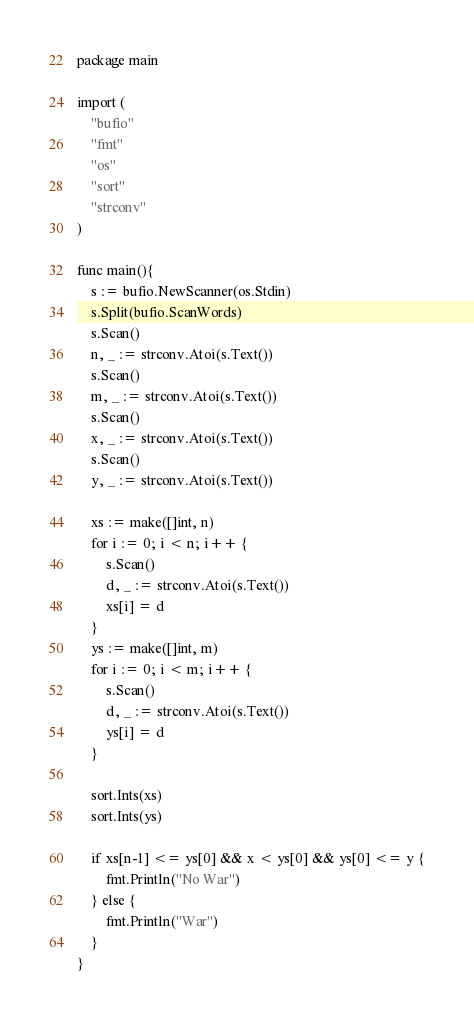Convert code to text. <code><loc_0><loc_0><loc_500><loc_500><_Go_>package main

import (
    "bufio"
    "fmt"
    "os"
    "sort"
    "strconv"
)    

func main(){
    s := bufio.NewScanner(os.Stdin)
    s.Split(bufio.ScanWords)
    s.Scan()
    n, _ := strconv.Atoi(s.Text())
    s.Scan()
    m, _ := strconv.Atoi(s.Text())
    s.Scan()
    x, _ := strconv.Atoi(s.Text())
    s.Scan()
    y, _ := strconv.Atoi(s.Text())
    
    xs := make([]int, n)
    for i := 0; i < n; i++ {
        s.Scan()
        d, _ := strconv.Atoi(s.Text())
        xs[i] = d
    }
    ys := make([]int, m)
    for i := 0; i < m; i++ {
        s.Scan()
        d, _ := strconv.Atoi(s.Text())
        ys[i] = d
    }
    
    sort.Ints(xs)
    sort.Ints(ys)
    
    if xs[n-1] <= ys[0] && x < ys[0] && ys[0] <= y {
        fmt.Println("No War")
    } else {
        fmt.Println("War")
    }
}</code> 